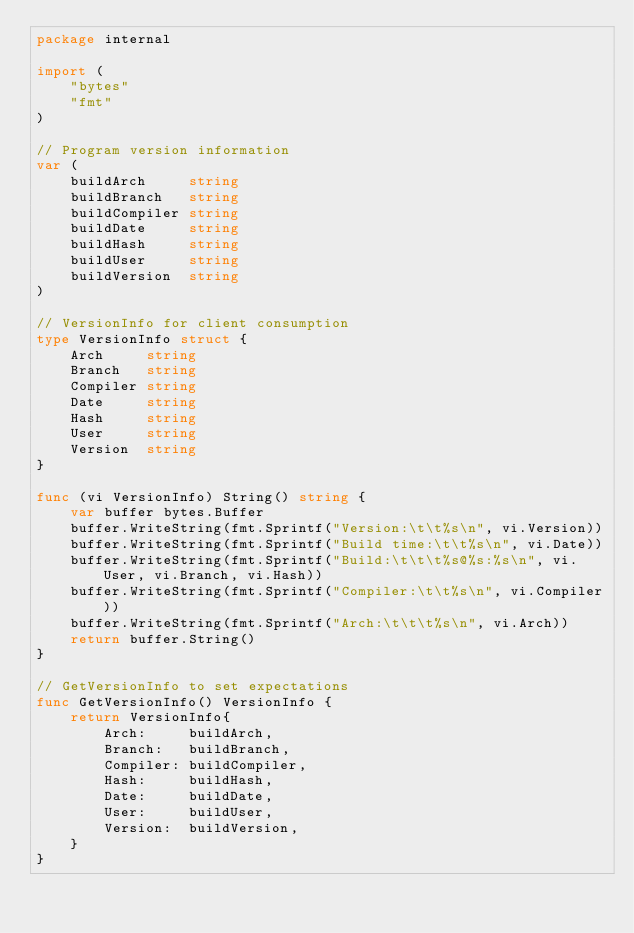Convert code to text. <code><loc_0><loc_0><loc_500><loc_500><_Go_>package internal

import (
	"bytes"
	"fmt"
)

// Program version information
var (
	buildArch     string
	buildBranch   string
	buildCompiler string
	buildDate     string
	buildHash     string
	buildUser     string
	buildVersion  string
)

// VersionInfo for client consumption
type VersionInfo struct {
	Arch     string
	Branch   string
	Compiler string
	Date     string
	Hash     string
	User     string
	Version  string
}

func (vi VersionInfo) String() string {
	var buffer bytes.Buffer
	buffer.WriteString(fmt.Sprintf("Version:\t\t%s\n", vi.Version))
	buffer.WriteString(fmt.Sprintf("Build time:\t\t%s\n", vi.Date))
	buffer.WriteString(fmt.Sprintf("Build:\t\t\t%s@%s:%s\n", vi.User, vi.Branch, vi.Hash))
	buffer.WriteString(fmt.Sprintf("Compiler:\t\t%s\n", vi.Compiler))
	buffer.WriteString(fmt.Sprintf("Arch:\t\t\t%s\n", vi.Arch))
	return buffer.String()
}

// GetVersionInfo to set expectations
func GetVersionInfo() VersionInfo {
	return VersionInfo{
		Arch:     buildArch,
		Branch:   buildBranch,
		Compiler: buildCompiler,
		Hash:     buildHash,
		Date:     buildDate,
		User:     buildUser,
		Version:  buildVersion,
	}
}

</code> 